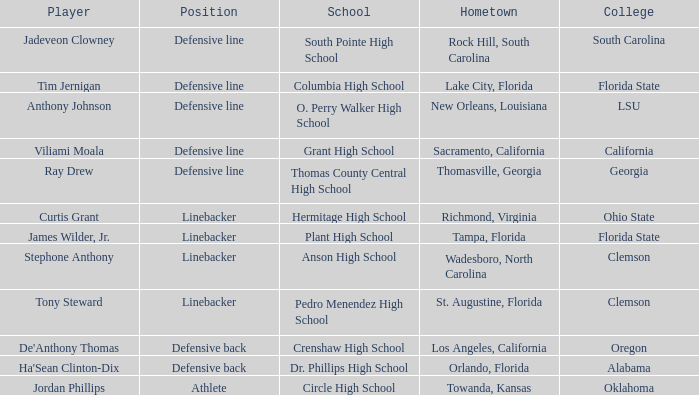Which university is jordan phillips representing? Oklahoma. 